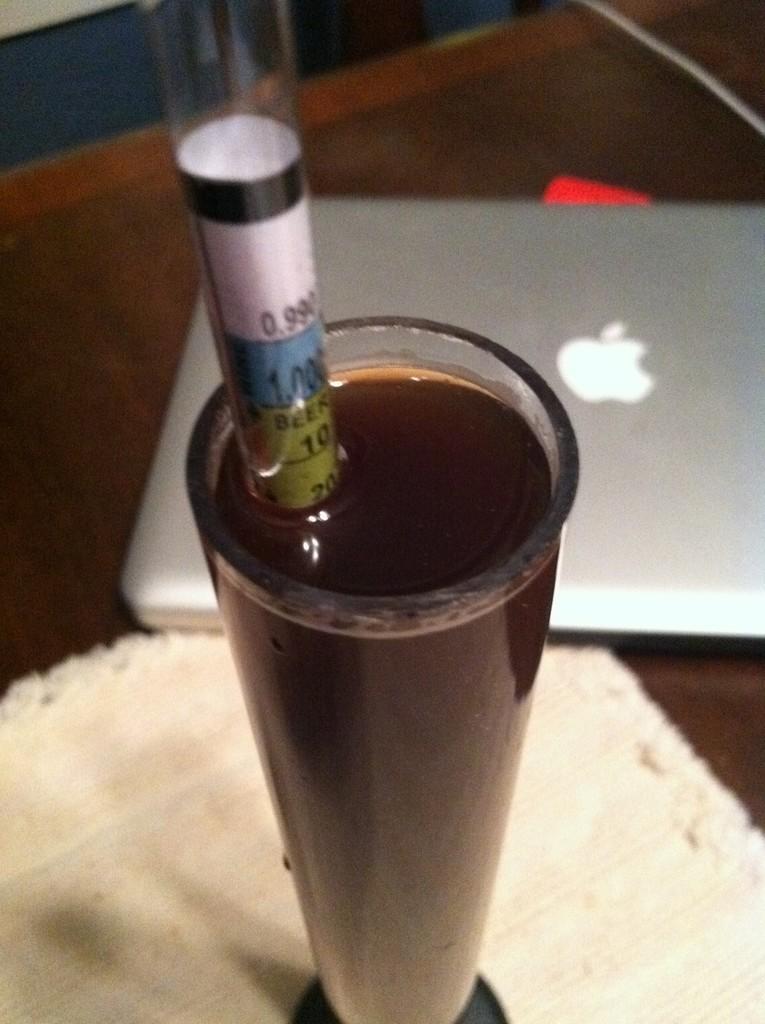Describe this image in one or two sentences. In this picture we can see glass with drink and tube, laptop and cloth the platform. 